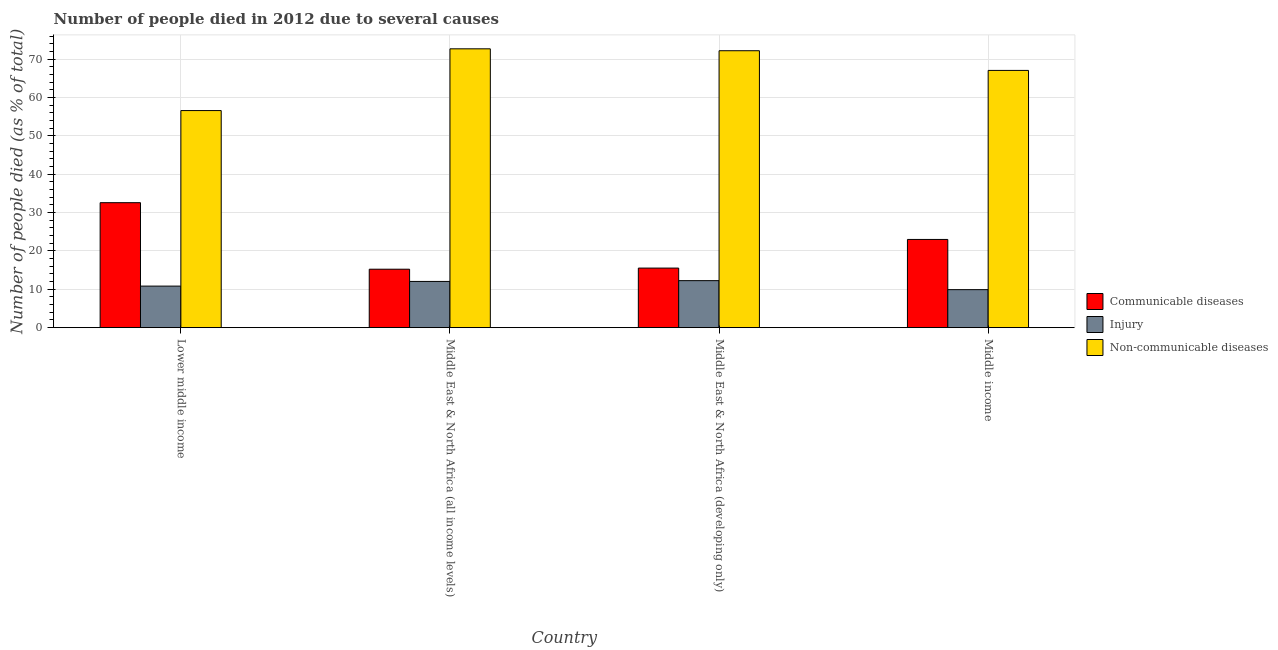How many groups of bars are there?
Provide a short and direct response. 4. Are the number of bars per tick equal to the number of legend labels?
Your answer should be compact. Yes. What is the label of the 2nd group of bars from the left?
Your answer should be very brief. Middle East & North Africa (all income levels). In how many cases, is the number of bars for a given country not equal to the number of legend labels?
Ensure brevity in your answer.  0. What is the number of people who dies of non-communicable diseases in Middle East & North Africa (all income levels)?
Provide a short and direct response. 72.72. Across all countries, what is the maximum number of people who dies of non-communicable diseases?
Offer a very short reply. 72.72. Across all countries, what is the minimum number of people who dies of non-communicable diseases?
Ensure brevity in your answer.  56.61. In which country was the number of people who died of injury maximum?
Ensure brevity in your answer.  Middle East & North Africa (developing only). In which country was the number of people who died of communicable diseases minimum?
Make the answer very short. Middle East & North Africa (all income levels). What is the total number of people who died of injury in the graph?
Offer a terse response. 45.07. What is the difference between the number of people who dies of non-communicable diseases in Lower middle income and that in Middle East & North Africa (developing only)?
Your answer should be very brief. -15.61. What is the difference between the number of people who dies of non-communicable diseases in Lower middle income and the number of people who died of communicable diseases in Middle East & North Africa (developing only)?
Keep it short and to the point. 41.08. What is the average number of people who dies of non-communicable diseases per country?
Your answer should be very brief. 67.16. What is the difference between the number of people who died of communicable diseases and number of people who dies of non-communicable diseases in Middle East & North Africa (developing only)?
Your response must be concise. -56.68. What is the ratio of the number of people who died of communicable diseases in Middle East & North Africa (developing only) to that in Middle income?
Give a very brief answer. 0.68. What is the difference between the highest and the second highest number of people who dies of non-communicable diseases?
Your answer should be very brief. 0.5. What is the difference between the highest and the lowest number of people who dies of non-communicable diseases?
Offer a very short reply. 16.1. In how many countries, is the number of people who dies of non-communicable diseases greater than the average number of people who dies of non-communicable diseases taken over all countries?
Offer a very short reply. 2. Is the sum of the number of people who died of communicable diseases in Middle East & North Africa (developing only) and Middle income greater than the maximum number of people who dies of non-communicable diseases across all countries?
Give a very brief answer. No. What does the 2nd bar from the left in Middle East & North Africa (all income levels) represents?
Offer a terse response. Injury. What does the 1st bar from the right in Middle East & North Africa (developing only) represents?
Offer a very short reply. Non-communicable diseases. Is it the case that in every country, the sum of the number of people who died of communicable diseases and number of people who died of injury is greater than the number of people who dies of non-communicable diseases?
Keep it short and to the point. No. Are all the bars in the graph horizontal?
Offer a very short reply. No. How many countries are there in the graph?
Your response must be concise. 4. Does the graph contain any zero values?
Make the answer very short. No. Where does the legend appear in the graph?
Provide a succinct answer. Center right. How many legend labels are there?
Offer a very short reply. 3. What is the title of the graph?
Keep it short and to the point. Number of people died in 2012 due to several causes. Does "Tertiary education" appear as one of the legend labels in the graph?
Ensure brevity in your answer.  No. What is the label or title of the X-axis?
Make the answer very short. Country. What is the label or title of the Y-axis?
Your response must be concise. Number of people died (as % of total). What is the Number of people died (as % of total) of Communicable diseases in Lower middle income?
Ensure brevity in your answer.  32.59. What is the Number of people died (as % of total) of Injury in Lower middle income?
Offer a terse response. 10.84. What is the Number of people died (as % of total) in Non-communicable diseases in Lower middle income?
Your answer should be very brief. 56.61. What is the Number of people died (as % of total) in Communicable diseases in Middle East & North Africa (all income levels)?
Give a very brief answer. 15.24. What is the Number of people died (as % of total) in Injury in Middle East & North Africa (all income levels)?
Your answer should be compact. 12.06. What is the Number of people died (as % of total) in Non-communicable diseases in Middle East & North Africa (all income levels)?
Give a very brief answer. 72.72. What is the Number of people died (as % of total) in Communicable diseases in Middle East & North Africa (developing only)?
Offer a terse response. 15.54. What is the Number of people died (as % of total) in Injury in Middle East & North Africa (developing only)?
Offer a terse response. 12.26. What is the Number of people died (as % of total) in Non-communicable diseases in Middle East & North Africa (developing only)?
Offer a terse response. 72.22. What is the Number of people died (as % of total) of Communicable diseases in Middle income?
Your answer should be very brief. 23. What is the Number of people died (as % of total) in Injury in Middle income?
Ensure brevity in your answer.  9.91. What is the Number of people died (as % of total) of Non-communicable diseases in Middle income?
Keep it short and to the point. 67.09. Across all countries, what is the maximum Number of people died (as % of total) of Communicable diseases?
Offer a terse response. 32.59. Across all countries, what is the maximum Number of people died (as % of total) in Injury?
Provide a succinct answer. 12.26. Across all countries, what is the maximum Number of people died (as % of total) of Non-communicable diseases?
Offer a terse response. 72.72. Across all countries, what is the minimum Number of people died (as % of total) of Communicable diseases?
Ensure brevity in your answer.  15.24. Across all countries, what is the minimum Number of people died (as % of total) of Injury?
Your answer should be very brief. 9.91. Across all countries, what is the minimum Number of people died (as % of total) of Non-communicable diseases?
Provide a succinct answer. 56.61. What is the total Number of people died (as % of total) in Communicable diseases in the graph?
Offer a terse response. 86.37. What is the total Number of people died (as % of total) in Injury in the graph?
Ensure brevity in your answer.  45.07. What is the total Number of people died (as % of total) in Non-communicable diseases in the graph?
Give a very brief answer. 268.63. What is the difference between the Number of people died (as % of total) in Communicable diseases in Lower middle income and that in Middle East & North Africa (all income levels)?
Make the answer very short. 17.35. What is the difference between the Number of people died (as % of total) in Injury in Lower middle income and that in Middle East & North Africa (all income levels)?
Provide a short and direct response. -1.22. What is the difference between the Number of people died (as % of total) of Non-communicable diseases in Lower middle income and that in Middle East & North Africa (all income levels)?
Your answer should be compact. -16.1. What is the difference between the Number of people died (as % of total) of Communicable diseases in Lower middle income and that in Middle East & North Africa (developing only)?
Provide a short and direct response. 17.06. What is the difference between the Number of people died (as % of total) of Injury in Lower middle income and that in Middle East & North Africa (developing only)?
Your answer should be compact. -1.42. What is the difference between the Number of people died (as % of total) in Non-communicable diseases in Lower middle income and that in Middle East & North Africa (developing only)?
Give a very brief answer. -15.61. What is the difference between the Number of people died (as % of total) of Communicable diseases in Lower middle income and that in Middle income?
Ensure brevity in your answer.  9.59. What is the difference between the Number of people died (as % of total) in Injury in Lower middle income and that in Middle income?
Provide a succinct answer. 0.93. What is the difference between the Number of people died (as % of total) of Non-communicable diseases in Lower middle income and that in Middle income?
Provide a succinct answer. -10.47. What is the difference between the Number of people died (as % of total) in Communicable diseases in Middle East & North Africa (all income levels) and that in Middle East & North Africa (developing only)?
Your response must be concise. -0.29. What is the difference between the Number of people died (as % of total) of Injury in Middle East & North Africa (all income levels) and that in Middle East & North Africa (developing only)?
Provide a short and direct response. -0.21. What is the difference between the Number of people died (as % of total) of Non-communicable diseases in Middle East & North Africa (all income levels) and that in Middle East & North Africa (developing only)?
Offer a terse response. 0.5. What is the difference between the Number of people died (as % of total) in Communicable diseases in Middle East & North Africa (all income levels) and that in Middle income?
Offer a terse response. -7.76. What is the difference between the Number of people died (as % of total) of Injury in Middle East & North Africa (all income levels) and that in Middle income?
Keep it short and to the point. 2.14. What is the difference between the Number of people died (as % of total) of Non-communicable diseases in Middle East & North Africa (all income levels) and that in Middle income?
Make the answer very short. 5.63. What is the difference between the Number of people died (as % of total) in Communicable diseases in Middle East & North Africa (developing only) and that in Middle income?
Offer a very short reply. -7.47. What is the difference between the Number of people died (as % of total) in Injury in Middle East & North Africa (developing only) and that in Middle income?
Make the answer very short. 2.35. What is the difference between the Number of people died (as % of total) of Non-communicable diseases in Middle East & North Africa (developing only) and that in Middle income?
Your answer should be compact. 5.13. What is the difference between the Number of people died (as % of total) in Communicable diseases in Lower middle income and the Number of people died (as % of total) in Injury in Middle East & North Africa (all income levels)?
Your response must be concise. 20.54. What is the difference between the Number of people died (as % of total) in Communicable diseases in Lower middle income and the Number of people died (as % of total) in Non-communicable diseases in Middle East & North Africa (all income levels)?
Your response must be concise. -40.12. What is the difference between the Number of people died (as % of total) in Injury in Lower middle income and the Number of people died (as % of total) in Non-communicable diseases in Middle East & North Africa (all income levels)?
Your answer should be compact. -61.88. What is the difference between the Number of people died (as % of total) of Communicable diseases in Lower middle income and the Number of people died (as % of total) of Injury in Middle East & North Africa (developing only)?
Offer a very short reply. 20.33. What is the difference between the Number of people died (as % of total) in Communicable diseases in Lower middle income and the Number of people died (as % of total) in Non-communicable diseases in Middle East & North Africa (developing only)?
Offer a terse response. -39.62. What is the difference between the Number of people died (as % of total) of Injury in Lower middle income and the Number of people died (as % of total) of Non-communicable diseases in Middle East & North Africa (developing only)?
Provide a succinct answer. -61.38. What is the difference between the Number of people died (as % of total) of Communicable diseases in Lower middle income and the Number of people died (as % of total) of Injury in Middle income?
Provide a short and direct response. 22.68. What is the difference between the Number of people died (as % of total) of Communicable diseases in Lower middle income and the Number of people died (as % of total) of Non-communicable diseases in Middle income?
Your response must be concise. -34.49. What is the difference between the Number of people died (as % of total) in Injury in Lower middle income and the Number of people died (as % of total) in Non-communicable diseases in Middle income?
Offer a very short reply. -56.25. What is the difference between the Number of people died (as % of total) in Communicable diseases in Middle East & North Africa (all income levels) and the Number of people died (as % of total) in Injury in Middle East & North Africa (developing only)?
Your answer should be compact. 2.98. What is the difference between the Number of people died (as % of total) in Communicable diseases in Middle East & North Africa (all income levels) and the Number of people died (as % of total) in Non-communicable diseases in Middle East & North Africa (developing only)?
Give a very brief answer. -56.98. What is the difference between the Number of people died (as % of total) in Injury in Middle East & North Africa (all income levels) and the Number of people died (as % of total) in Non-communicable diseases in Middle East & North Africa (developing only)?
Provide a short and direct response. -60.16. What is the difference between the Number of people died (as % of total) of Communicable diseases in Middle East & North Africa (all income levels) and the Number of people died (as % of total) of Injury in Middle income?
Your response must be concise. 5.33. What is the difference between the Number of people died (as % of total) in Communicable diseases in Middle East & North Africa (all income levels) and the Number of people died (as % of total) in Non-communicable diseases in Middle income?
Offer a very short reply. -51.84. What is the difference between the Number of people died (as % of total) in Injury in Middle East & North Africa (all income levels) and the Number of people died (as % of total) in Non-communicable diseases in Middle income?
Your answer should be compact. -55.03. What is the difference between the Number of people died (as % of total) in Communicable diseases in Middle East & North Africa (developing only) and the Number of people died (as % of total) in Injury in Middle income?
Your response must be concise. 5.62. What is the difference between the Number of people died (as % of total) in Communicable diseases in Middle East & North Africa (developing only) and the Number of people died (as % of total) in Non-communicable diseases in Middle income?
Keep it short and to the point. -51.55. What is the difference between the Number of people died (as % of total) in Injury in Middle East & North Africa (developing only) and the Number of people died (as % of total) in Non-communicable diseases in Middle income?
Make the answer very short. -54.82. What is the average Number of people died (as % of total) of Communicable diseases per country?
Offer a terse response. 21.59. What is the average Number of people died (as % of total) in Injury per country?
Make the answer very short. 11.27. What is the average Number of people died (as % of total) in Non-communicable diseases per country?
Offer a terse response. 67.16. What is the difference between the Number of people died (as % of total) of Communicable diseases and Number of people died (as % of total) of Injury in Lower middle income?
Your answer should be compact. 21.75. What is the difference between the Number of people died (as % of total) in Communicable diseases and Number of people died (as % of total) in Non-communicable diseases in Lower middle income?
Offer a very short reply. -24.02. What is the difference between the Number of people died (as % of total) in Injury and Number of people died (as % of total) in Non-communicable diseases in Lower middle income?
Your answer should be very brief. -45.77. What is the difference between the Number of people died (as % of total) of Communicable diseases and Number of people died (as % of total) of Injury in Middle East & North Africa (all income levels)?
Offer a terse response. 3.19. What is the difference between the Number of people died (as % of total) in Communicable diseases and Number of people died (as % of total) in Non-communicable diseases in Middle East & North Africa (all income levels)?
Offer a terse response. -57.48. What is the difference between the Number of people died (as % of total) of Injury and Number of people died (as % of total) of Non-communicable diseases in Middle East & North Africa (all income levels)?
Keep it short and to the point. -60.66. What is the difference between the Number of people died (as % of total) in Communicable diseases and Number of people died (as % of total) in Injury in Middle East & North Africa (developing only)?
Keep it short and to the point. 3.27. What is the difference between the Number of people died (as % of total) of Communicable diseases and Number of people died (as % of total) of Non-communicable diseases in Middle East & North Africa (developing only)?
Provide a short and direct response. -56.68. What is the difference between the Number of people died (as % of total) in Injury and Number of people died (as % of total) in Non-communicable diseases in Middle East & North Africa (developing only)?
Provide a short and direct response. -59.96. What is the difference between the Number of people died (as % of total) in Communicable diseases and Number of people died (as % of total) in Injury in Middle income?
Your answer should be very brief. 13.09. What is the difference between the Number of people died (as % of total) in Communicable diseases and Number of people died (as % of total) in Non-communicable diseases in Middle income?
Your response must be concise. -44.08. What is the difference between the Number of people died (as % of total) of Injury and Number of people died (as % of total) of Non-communicable diseases in Middle income?
Your answer should be compact. -57.17. What is the ratio of the Number of people died (as % of total) in Communicable diseases in Lower middle income to that in Middle East & North Africa (all income levels)?
Your answer should be very brief. 2.14. What is the ratio of the Number of people died (as % of total) of Injury in Lower middle income to that in Middle East & North Africa (all income levels)?
Your answer should be very brief. 0.9. What is the ratio of the Number of people died (as % of total) of Non-communicable diseases in Lower middle income to that in Middle East & North Africa (all income levels)?
Provide a short and direct response. 0.78. What is the ratio of the Number of people died (as % of total) of Communicable diseases in Lower middle income to that in Middle East & North Africa (developing only)?
Ensure brevity in your answer.  2.1. What is the ratio of the Number of people died (as % of total) of Injury in Lower middle income to that in Middle East & North Africa (developing only)?
Give a very brief answer. 0.88. What is the ratio of the Number of people died (as % of total) of Non-communicable diseases in Lower middle income to that in Middle East & North Africa (developing only)?
Offer a terse response. 0.78. What is the ratio of the Number of people died (as % of total) in Communicable diseases in Lower middle income to that in Middle income?
Give a very brief answer. 1.42. What is the ratio of the Number of people died (as % of total) in Injury in Lower middle income to that in Middle income?
Make the answer very short. 1.09. What is the ratio of the Number of people died (as % of total) of Non-communicable diseases in Lower middle income to that in Middle income?
Provide a succinct answer. 0.84. What is the ratio of the Number of people died (as % of total) in Communicable diseases in Middle East & North Africa (all income levels) to that in Middle East & North Africa (developing only)?
Your answer should be very brief. 0.98. What is the ratio of the Number of people died (as % of total) in Injury in Middle East & North Africa (all income levels) to that in Middle East & North Africa (developing only)?
Offer a very short reply. 0.98. What is the ratio of the Number of people died (as % of total) in Communicable diseases in Middle East & North Africa (all income levels) to that in Middle income?
Provide a succinct answer. 0.66. What is the ratio of the Number of people died (as % of total) in Injury in Middle East & North Africa (all income levels) to that in Middle income?
Your response must be concise. 1.22. What is the ratio of the Number of people died (as % of total) of Non-communicable diseases in Middle East & North Africa (all income levels) to that in Middle income?
Offer a very short reply. 1.08. What is the ratio of the Number of people died (as % of total) in Communicable diseases in Middle East & North Africa (developing only) to that in Middle income?
Your answer should be compact. 0.68. What is the ratio of the Number of people died (as % of total) of Injury in Middle East & North Africa (developing only) to that in Middle income?
Offer a terse response. 1.24. What is the ratio of the Number of people died (as % of total) of Non-communicable diseases in Middle East & North Africa (developing only) to that in Middle income?
Make the answer very short. 1.08. What is the difference between the highest and the second highest Number of people died (as % of total) in Communicable diseases?
Give a very brief answer. 9.59. What is the difference between the highest and the second highest Number of people died (as % of total) of Injury?
Keep it short and to the point. 0.21. What is the difference between the highest and the second highest Number of people died (as % of total) in Non-communicable diseases?
Give a very brief answer. 0.5. What is the difference between the highest and the lowest Number of people died (as % of total) in Communicable diseases?
Your answer should be compact. 17.35. What is the difference between the highest and the lowest Number of people died (as % of total) of Injury?
Your answer should be compact. 2.35. What is the difference between the highest and the lowest Number of people died (as % of total) in Non-communicable diseases?
Offer a very short reply. 16.1. 